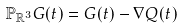<formula> <loc_0><loc_0><loc_500><loc_500>\mathbb { P } _ { \mathbb { R } ^ { 3 } } G ( t ) = G ( t ) - \nabla Q ( t )</formula> 